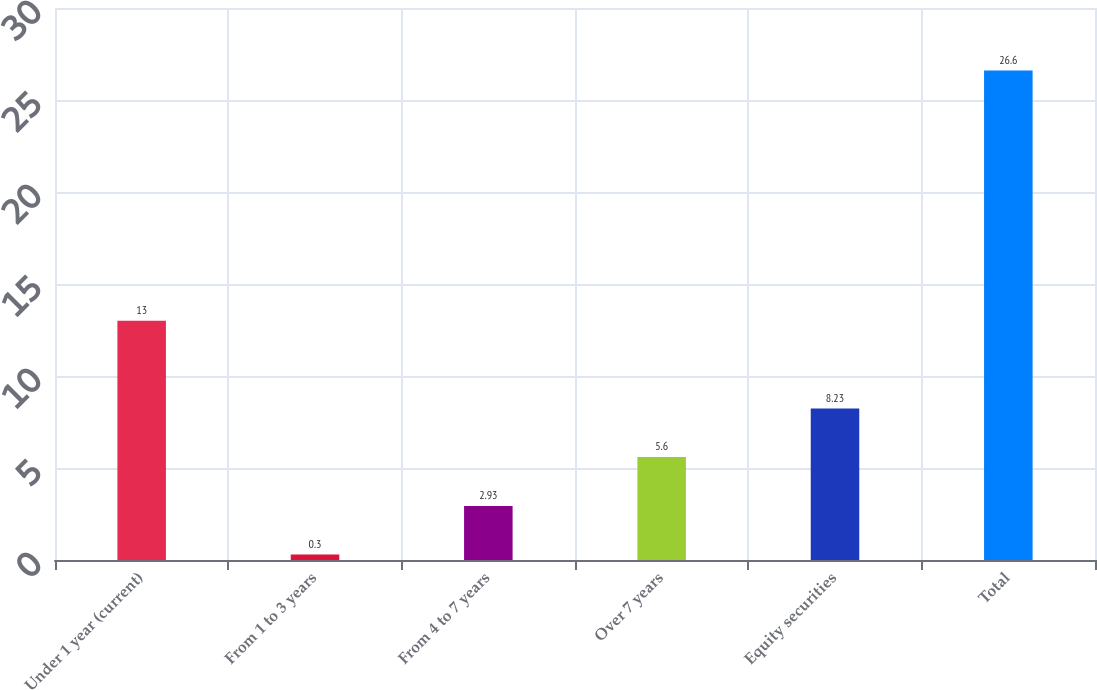Convert chart to OTSL. <chart><loc_0><loc_0><loc_500><loc_500><bar_chart><fcel>Under 1 year (current)<fcel>From 1 to 3 years<fcel>From 4 to 7 years<fcel>Over 7 years<fcel>Equity securities<fcel>Total<nl><fcel>13<fcel>0.3<fcel>2.93<fcel>5.6<fcel>8.23<fcel>26.6<nl></chart> 